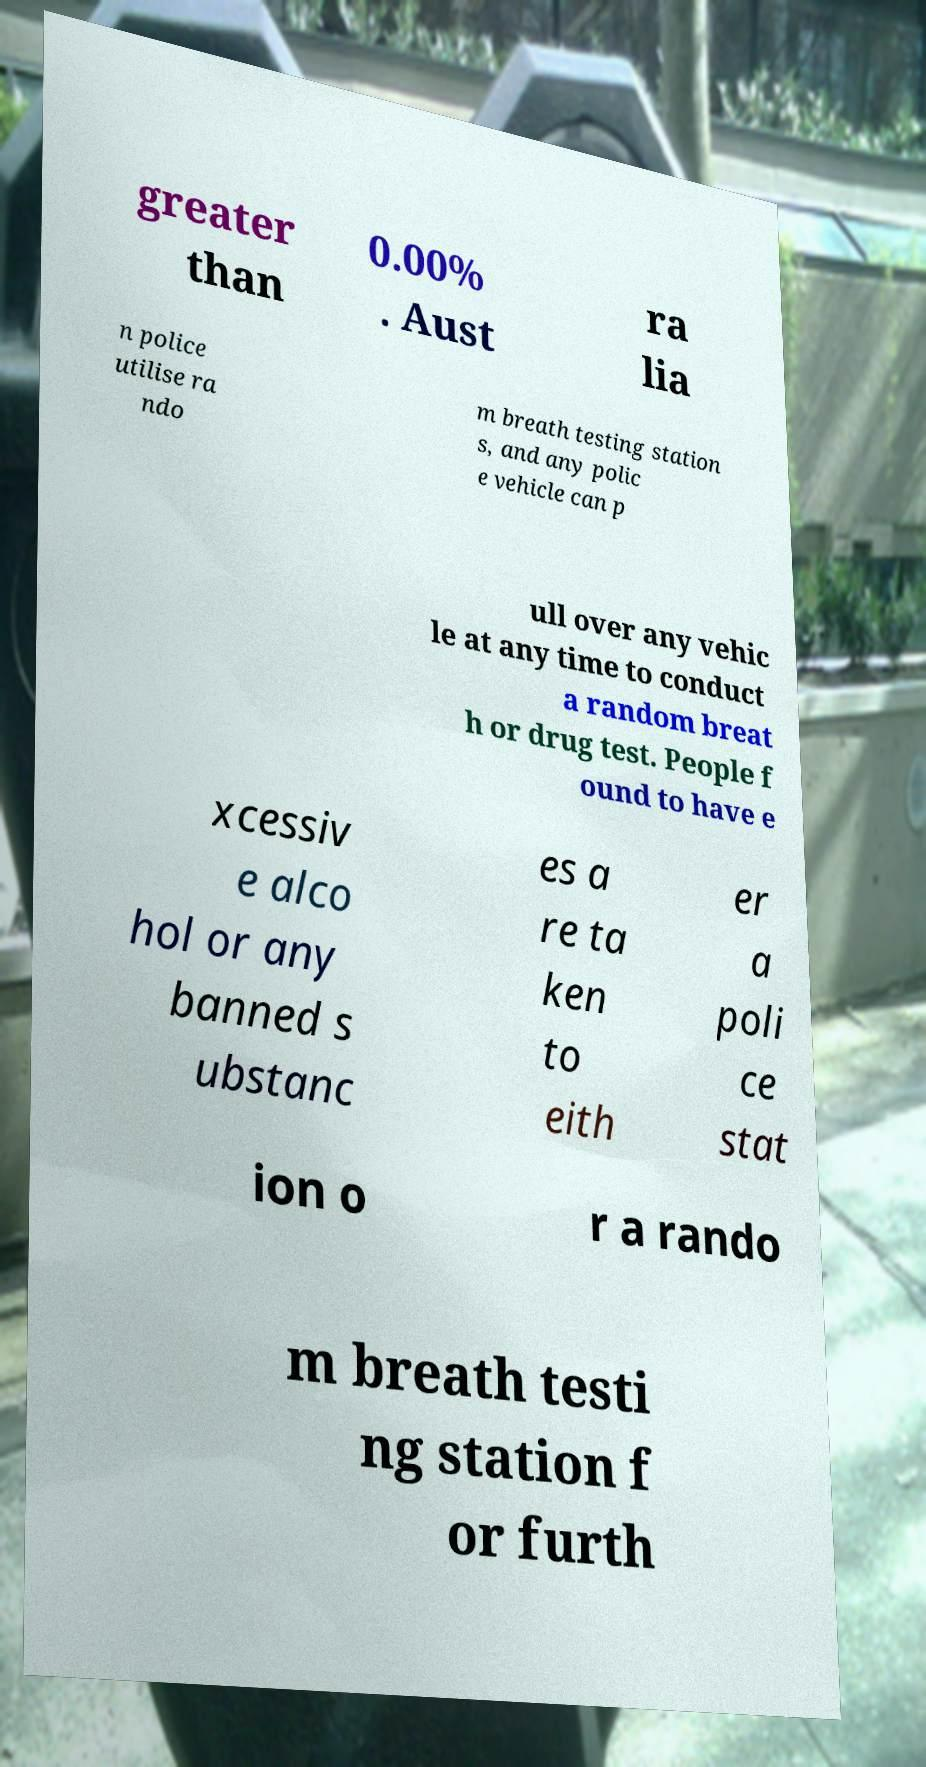For documentation purposes, I need the text within this image transcribed. Could you provide that? greater than 0.00% . Aust ra lia n police utilise ra ndo m breath testing station s, and any polic e vehicle can p ull over any vehic le at any time to conduct a random breat h or drug test. People f ound to have e xcessiv e alco hol or any banned s ubstanc es a re ta ken to eith er a poli ce stat ion o r a rando m breath testi ng station f or furth 